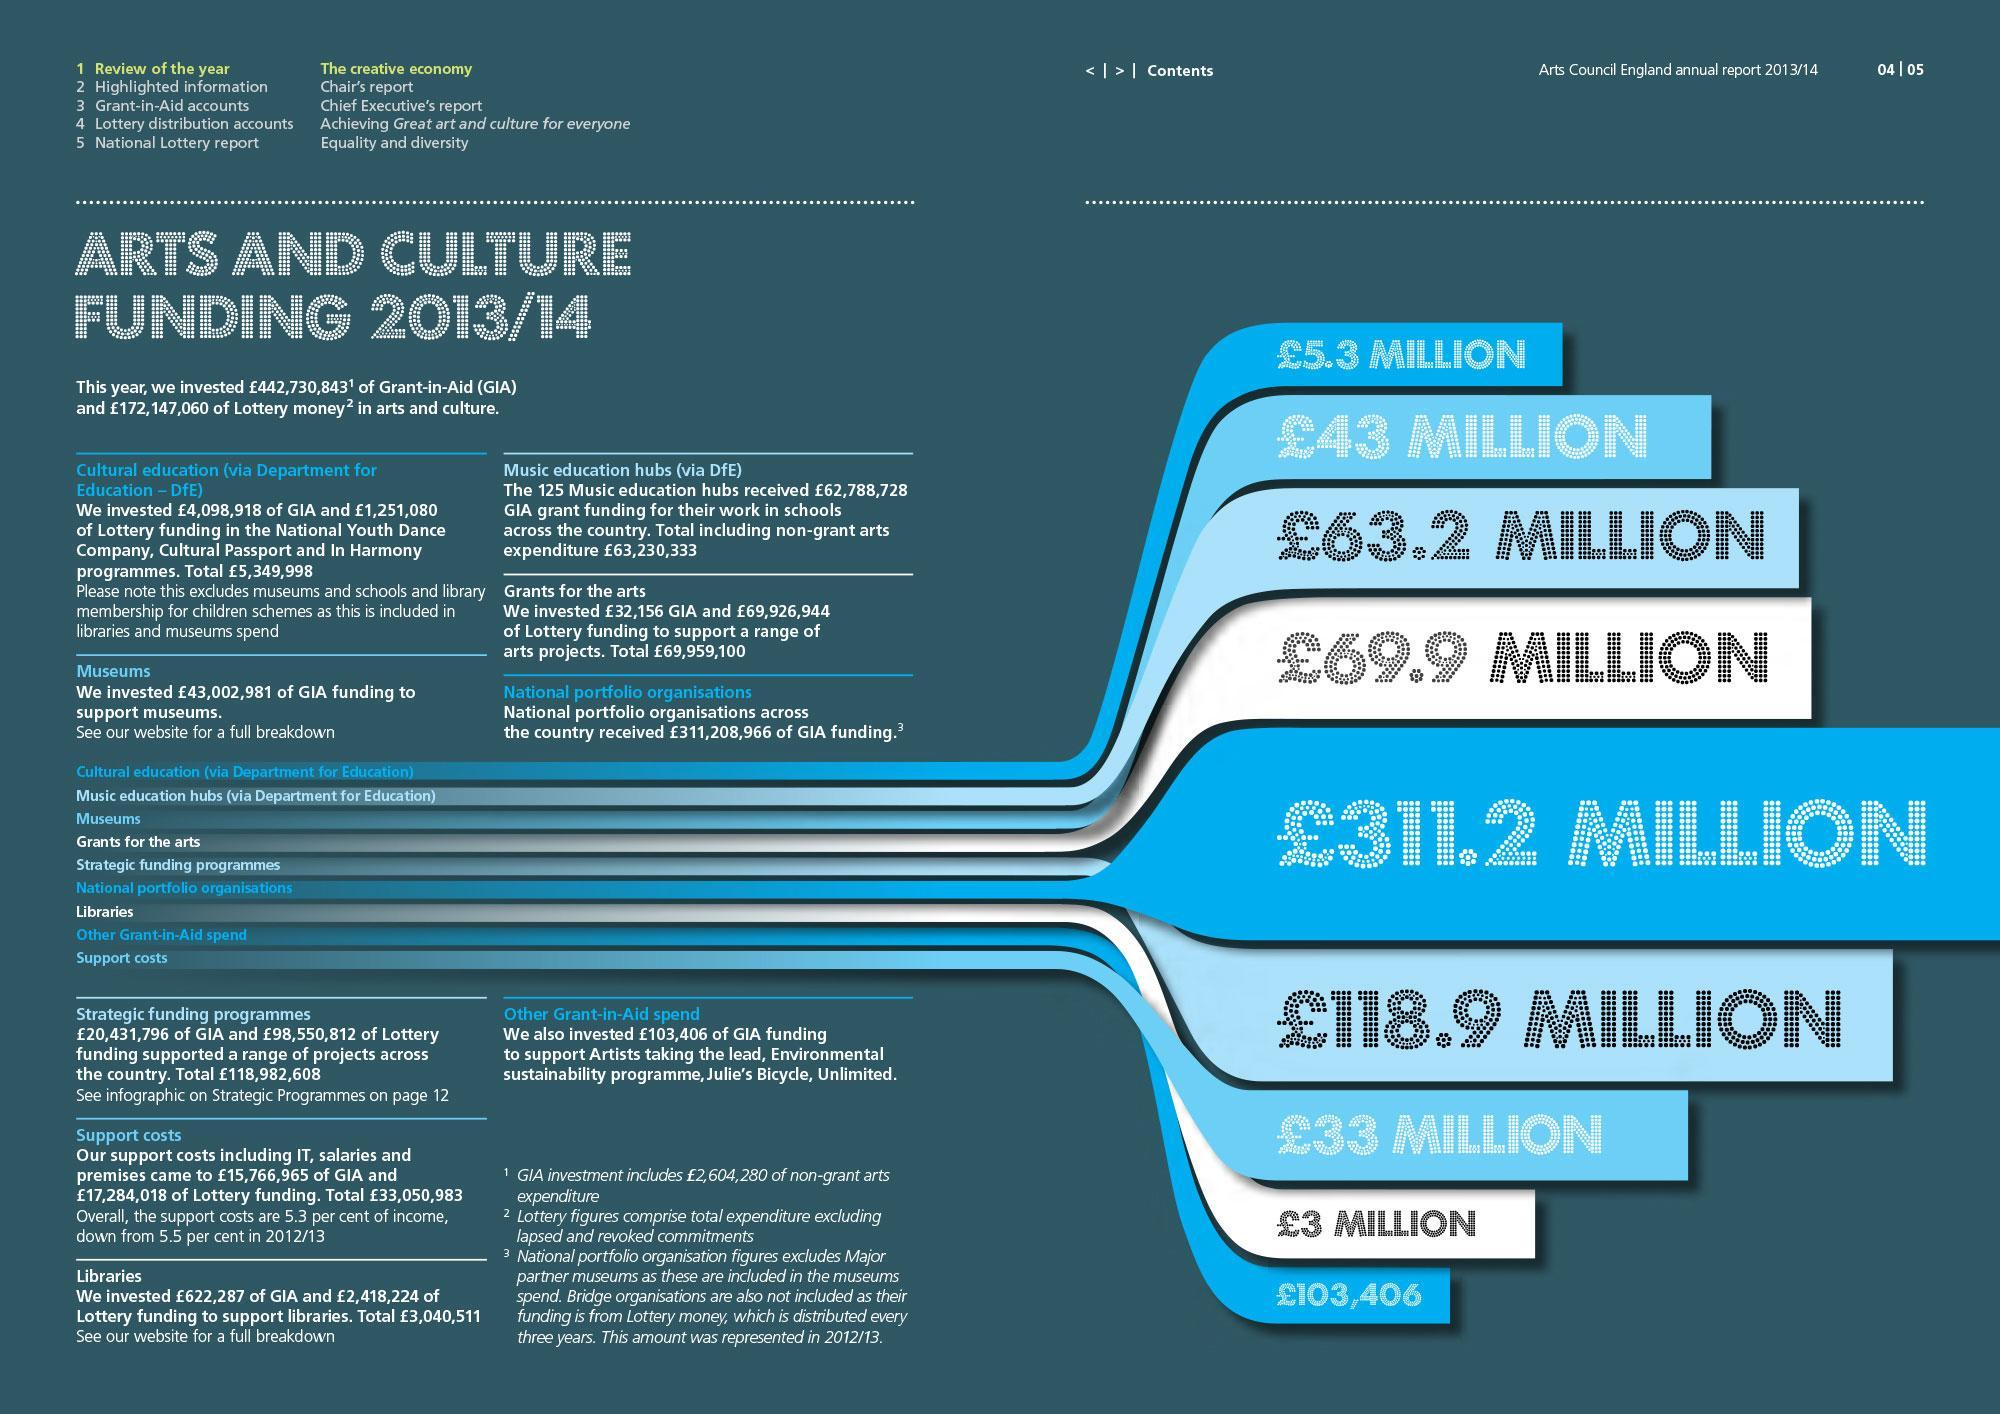What is the amount received as grants for the arts in pounds, 63.2 Mn, 69.9 Mn or 43 Mn?
Answer the question with a short phrase. 69.9 Mn What is the amount received towards support costs in pounds, 118.9 Mn, 33 Mn, or 3Mn? 33 Mn What is total grant received for cultural education and national portfolio organizations in pounds? 316.5 Mn What is the least amount received in pounds for Arts and Culture funding? 103,406 Which organization has received 63.2 Mn pounds, Museums, Libraries, or Music Education Hubs? Museums What is the highest amount received in pounds Arts and Culture funding? 311.2 Million Which organization has received 3 Mn pounds, Music Education Hubs, Libraries, or Museums, ? Libraries 